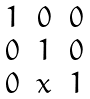Convert formula to latex. <formula><loc_0><loc_0><loc_500><loc_500>\begin{matrix} 1 & 0 & 0 \\ 0 & 1 & 0 \\ 0 & x & 1 \end{matrix}</formula> 